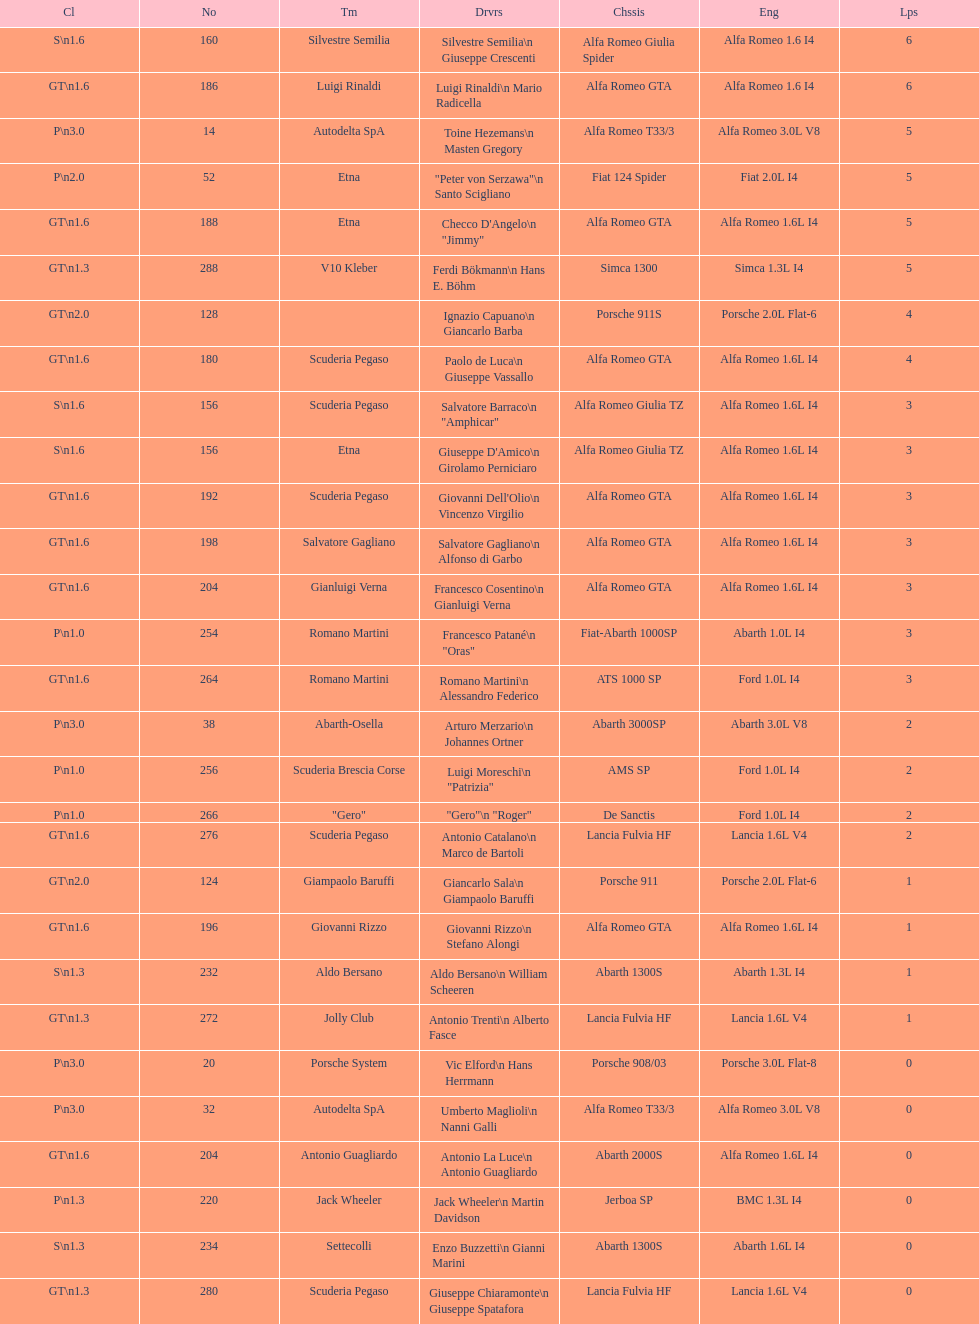Which chassis is in the middle of simca 1300 and alfa romeo gta? Porsche 911S. Parse the table in full. {'header': ['Cl', 'No', 'Tm', 'Drvrs', 'Chssis', 'Eng', 'Lps'], 'rows': [['S\\n1.6', '160', 'Silvestre Semilia', 'Silvestre Semilia\\n Giuseppe Crescenti', 'Alfa Romeo Giulia Spider', 'Alfa Romeo 1.6 I4', '6'], ['GT\\n1.6', '186', 'Luigi Rinaldi', 'Luigi Rinaldi\\n Mario Radicella', 'Alfa Romeo GTA', 'Alfa Romeo 1.6 I4', '6'], ['P\\n3.0', '14', 'Autodelta SpA', 'Toine Hezemans\\n Masten Gregory', 'Alfa Romeo T33/3', 'Alfa Romeo 3.0L V8', '5'], ['P\\n2.0', '52', 'Etna', '"Peter von Serzawa"\\n Santo Scigliano', 'Fiat 124 Spider', 'Fiat 2.0L I4', '5'], ['GT\\n1.6', '188', 'Etna', 'Checco D\'Angelo\\n "Jimmy"', 'Alfa Romeo GTA', 'Alfa Romeo 1.6L I4', '5'], ['GT\\n1.3', '288', 'V10 Kleber', 'Ferdi Bökmann\\n Hans E. Böhm', 'Simca 1300', 'Simca 1.3L I4', '5'], ['GT\\n2.0', '128', '', 'Ignazio Capuano\\n Giancarlo Barba', 'Porsche 911S', 'Porsche 2.0L Flat-6', '4'], ['GT\\n1.6', '180', 'Scuderia Pegaso', 'Paolo de Luca\\n Giuseppe Vassallo', 'Alfa Romeo GTA', 'Alfa Romeo 1.6L I4', '4'], ['S\\n1.6', '156', 'Scuderia Pegaso', 'Salvatore Barraco\\n "Amphicar"', 'Alfa Romeo Giulia TZ', 'Alfa Romeo 1.6L I4', '3'], ['S\\n1.6', '156', 'Etna', "Giuseppe D'Amico\\n Girolamo Perniciaro", 'Alfa Romeo Giulia TZ', 'Alfa Romeo 1.6L I4', '3'], ['GT\\n1.6', '192', 'Scuderia Pegaso', "Giovanni Dell'Olio\\n Vincenzo Virgilio", 'Alfa Romeo GTA', 'Alfa Romeo 1.6L I4', '3'], ['GT\\n1.6', '198', 'Salvatore Gagliano', 'Salvatore Gagliano\\n Alfonso di Garbo', 'Alfa Romeo GTA', 'Alfa Romeo 1.6L I4', '3'], ['GT\\n1.6', '204', 'Gianluigi Verna', 'Francesco Cosentino\\n Gianluigi Verna', 'Alfa Romeo GTA', 'Alfa Romeo 1.6L I4', '3'], ['P\\n1.0', '254', 'Romano Martini', 'Francesco Patané\\n "Oras"', 'Fiat-Abarth 1000SP', 'Abarth 1.0L I4', '3'], ['GT\\n1.6', '264', 'Romano Martini', 'Romano Martini\\n Alessandro Federico', 'ATS 1000 SP', 'Ford 1.0L I4', '3'], ['P\\n3.0', '38', 'Abarth-Osella', 'Arturo Merzario\\n Johannes Ortner', 'Abarth 3000SP', 'Abarth 3.0L V8', '2'], ['P\\n1.0', '256', 'Scuderia Brescia Corse', 'Luigi Moreschi\\n "Patrizia"', 'AMS SP', 'Ford 1.0L I4', '2'], ['P\\n1.0', '266', '"Gero"', '"Gero"\\n "Roger"', 'De Sanctis', 'Ford 1.0L I4', '2'], ['GT\\n1.6', '276', 'Scuderia Pegaso', 'Antonio Catalano\\n Marco de Bartoli', 'Lancia Fulvia HF', 'Lancia 1.6L V4', '2'], ['GT\\n2.0', '124', 'Giampaolo Baruffi', 'Giancarlo Sala\\n Giampaolo Baruffi', 'Porsche 911', 'Porsche 2.0L Flat-6', '1'], ['GT\\n1.6', '196', 'Giovanni Rizzo', 'Giovanni Rizzo\\n Stefano Alongi', 'Alfa Romeo GTA', 'Alfa Romeo 1.6L I4', '1'], ['S\\n1.3', '232', 'Aldo Bersano', 'Aldo Bersano\\n William Scheeren', 'Abarth 1300S', 'Abarth 1.3L I4', '1'], ['GT\\n1.3', '272', 'Jolly Club', 'Antonio Trenti\\n Alberto Fasce', 'Lancia Fulvia HF', 'Lancia 1.6L V4', '1'], ['P\\n3.0', '20', 'Porsche System', 'Vic Elford\\n Hans Herrmann', 'Porsche 908/03', 'Porsche 3.0L Flat-8', '0'], ['P\\n3.0', '32', 'Autodelta SpA', 'Umberto Maglioli\\n Nanni Galli', 'Alfa Romeo T33/3', 'Alfa Romeo 3.0L V8', '0'], ['GT\\n1.6', '204', 'Antonio Guagliardo', 'Antonio La Luce\\n Antonio Guagliardo', 'Abarth 2000S', 'Alfa Romeo 1.6L I4', '0'], ['P\\n1.3', '220', 'Jack Wheeler', 'Jack Wheeler\\n Martin Davidson', 'Jerboa SP', 'BMC 1.3L I4', '0'], ['S\\n1.3', '234', 'Settecolli', 'Enzo Buzzetti\\n Gianni Marini', 'Abarth 1300S', 'Abarth 1.6L I4', '0'], ['GT\\n1.3', '280', 'Scuderia Pegaso', 'Giuseppe Chiaramonte\\n Giuseppe Spatafora', 'Lancia Fulvia HF', 'Lancia 1.6L V4', '0']]} 